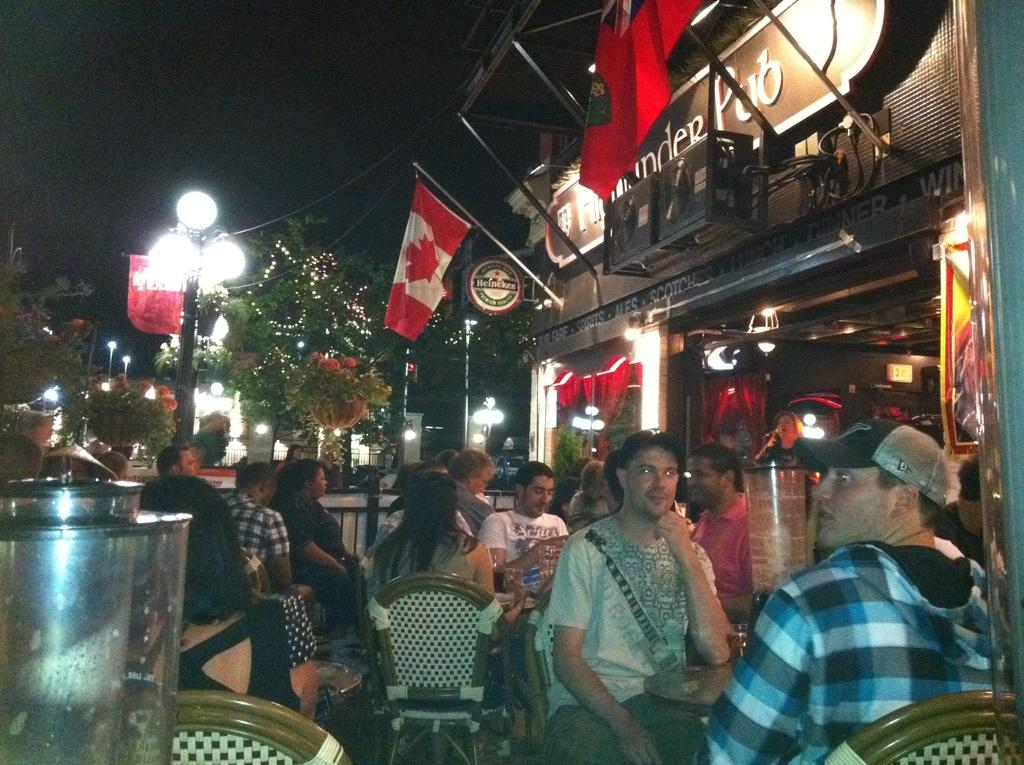What are the people in the image doing? The people in the image are sitting on chairs in front of a store. What decorative elements can be seen on the wall? There are flags on the wall. What object is on the floor in the image? There is a light pole on the floor. What type of natural elements are visible in the image? Trees are visible in the image. What type of bean is being used to make the stew in the image? There is no bean or stew present in the image. What kind of test is being conducted in the image? There is no test being conducted in the image. 